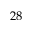Convert formula to latex. <formula><loc_0><loc_0><loc_500><loc_500>2 8</formula> 